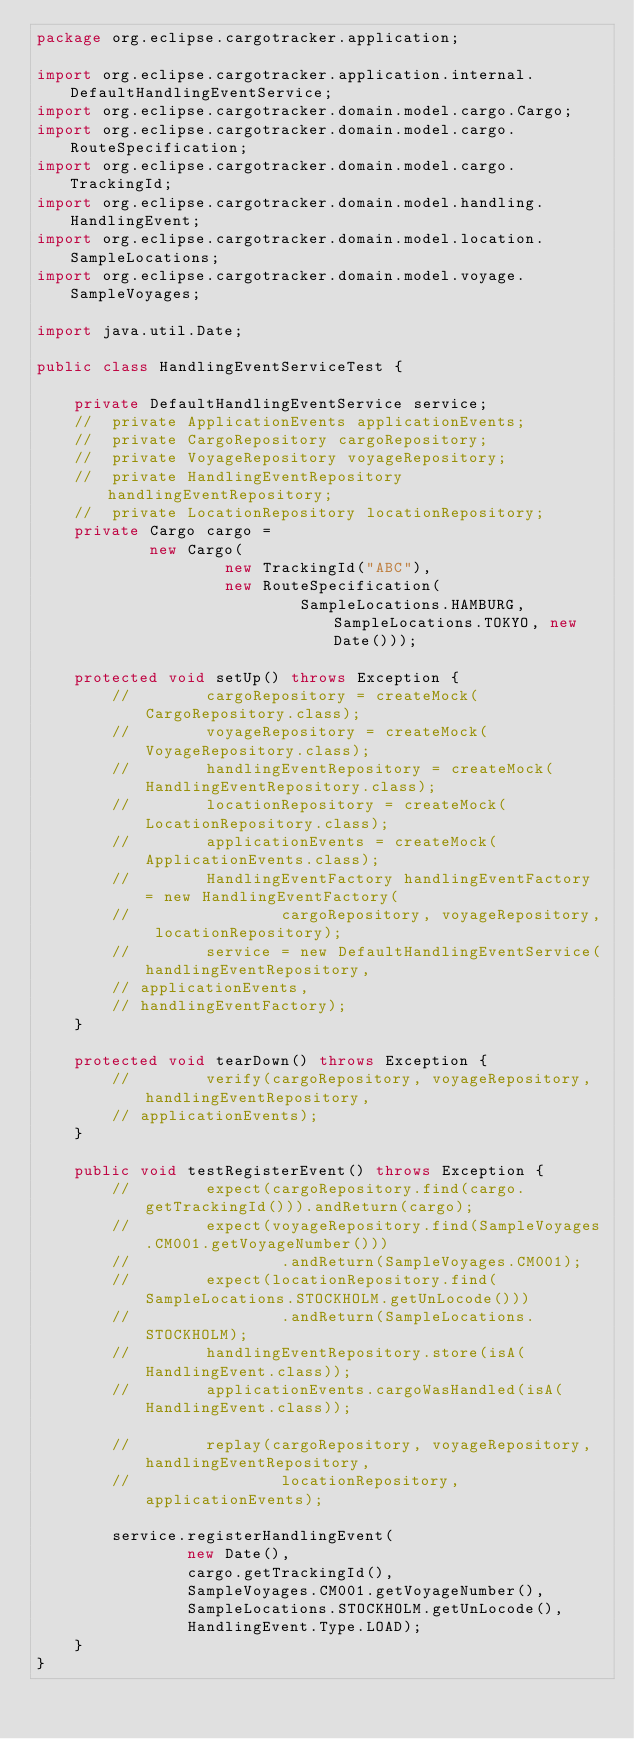<code> <loc_0><loc_0><loc_500><loc_500><_Java_>package org.eclipse.cargotracker.application;

import org.eclipse.cargotracker.application.internal.DefaultHandlingEventService;
import org.eclipse.cargotracker.domain.model.cargo.Cargo;
import org.eclipse.cargotracker.domain.model.cargo.RouteSpecification;
import org.eclipse.cargotracker.domain.model.cargo.TrackingId;
import org.eclipse.cargotracker.domain.model.handling.HandlingEvent;
import org.eclipse.cargotracker.domain.model.location.SampleLocations;
import org.eclipse.cargotracker.domain.model.voyage.SampleVoyages;

import java.util.Date;

public class HandlingEventServiceTest {

    private DefaultHandlingEventService service;
    //	private ApplicationEvents applicationEvents;
    //	private CargoRepository cargoRepository;
    //	private VoyageRepository voyageRepository;
    //	private HandlingEventRepository handlingEventRepository;
    //	private LocationRepository locationRepository;
    private Cargo cargo =
            new Cargo(
                    new TrackingId("ABC"),
                    new RouteSpecification(
                            SampleLocations.HAMBURG, SampleLocations.TOKYO, new Date()));

    protected void setUp() throws Exception {
        //        cargoRepository = createMock(CargoRepository.class);
        //        voyageRepository = createMock(VoyageRepository.class);
        //        handlingEventRepository = createMock(HandlingEventRepository.class);
        //        locationRepository = createMock(LocationRepository.class);
        //        applicationEvents = createMock(ApplicationEvents.class);
        //        HandlingEventFactory handlingEventFactory = new HandlingEventFactory(
        //                cargoRepository, voyageRepository, locationRepository);
        //        service = new DefaultHandlingEventService(handlingEventRepository,
        // applicationEvents,
        // handlingEventFactory);
    }

    protected void tearDown() throws Exception {
        //        verify(cargoRepository, voyageRepository, handlingEventRepository,
        // applicationEvents);
    }

    public void testRegisterEvent() throws Exception {
        //        expect(cargoRepository.find(cargo.getTrackingId())).andReturn(cargo);
        //        expect(voyageRepository.find(SampleVoyages.CM001.getVoyageNumber()))
        //                .andReturn(SampleVoyages.CM001);
        //        expect(locationRepository.find(SampleLocations.STOCKHOLM.getUnLocode()))
        //                .andReturn(SampleLocations.STOCKHOLM);
        //        handlingEventRepository.store(isA(HandlingEvent.class));
        //        applicationEvents.cargoWasHandled(isA(HandlingEvent.class));

        //        replay(cargoRepository, voyageRepository, handlingEventRepository,
        //                locationRepository, applicationEvents);

        service.registerHandlingEvent(
                new Date(),
                cargo.getTrackingId(),
                SampleVoyages.CM001.getVoyageNumber(),
                SampleLocations.STOCKHOLM.getUnLocode(),
                HandlingEvent.Type.LOAD);
    }
}
</code> 